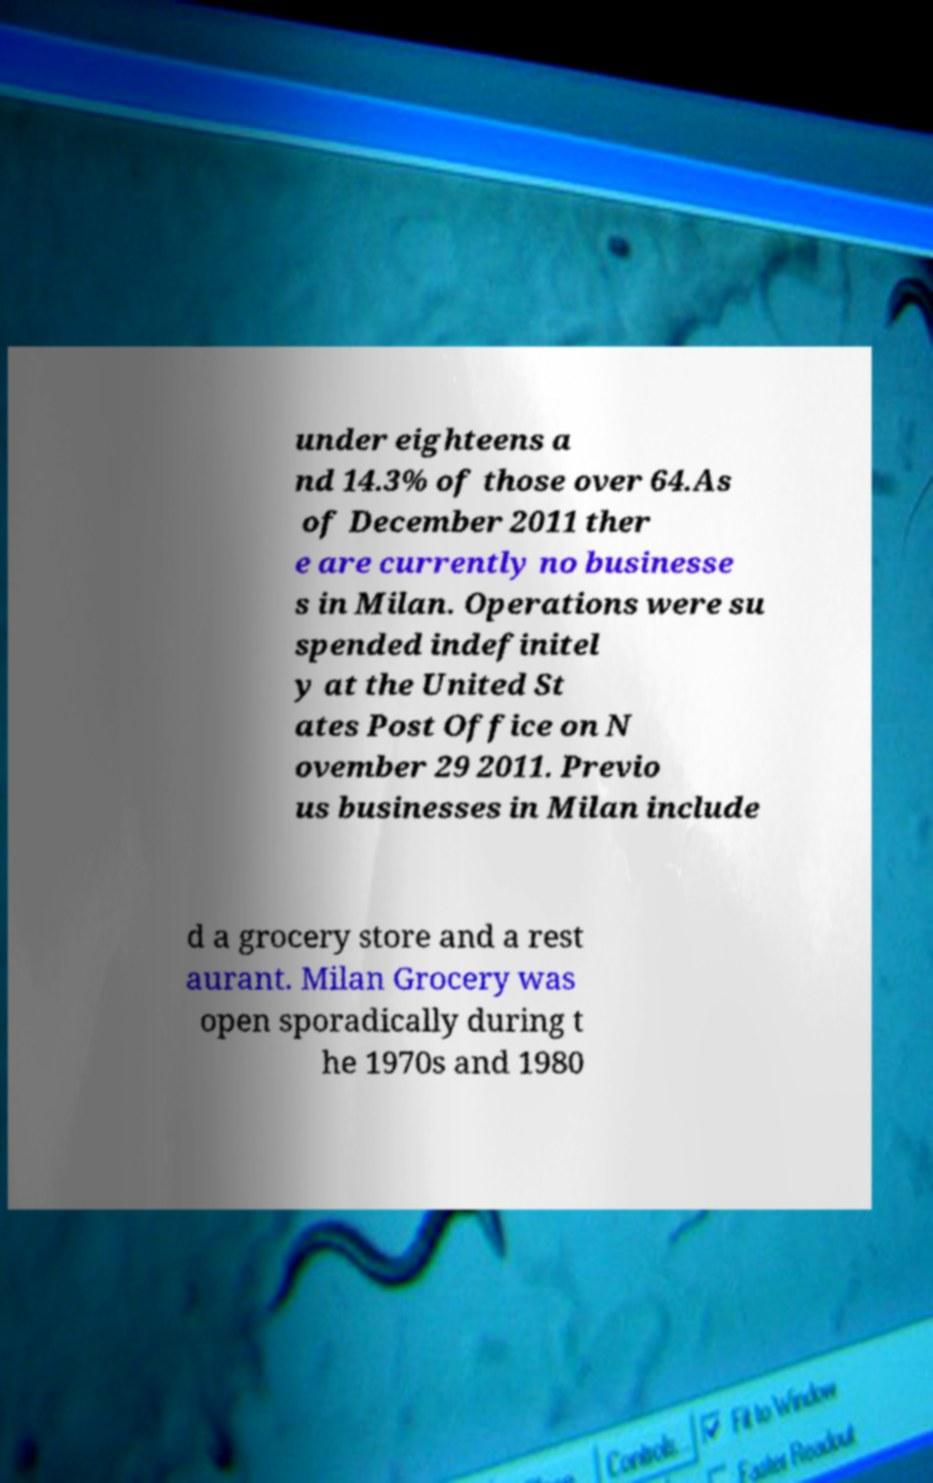What messages or text are displayed in this image? I need them in a readable, typed format. under eighteens a nd 14.3% of those over 64.As of December 2011 ther e are currently no businesse s in Milan. Operations were su spended indefinitel y at the United St ates Post Office on N ovember 29 2011. Previo us businesses in Milan include d a grocery store and a rest aurant. Milan Grocery was open sporadically during t he 1970s and 1980 